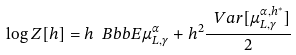<formula> <loc_0><loc_0><loc_500><loc_500>\log Z [ h ] = h { \ B b b E } \mu ^ { \alpha } _ { L , \gamma } + h ^ { 2 } \frac { \ V a r [ \mu ^ { \alpha , h ^ { * } } _ { L , \gamma } ] } { 2 }</formula> 